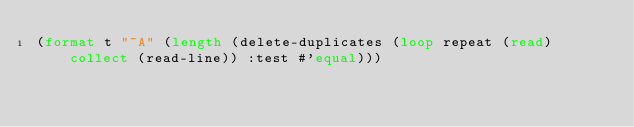Convert code to text. <code><loc_0><loc_0><loc_500><loc_500><_Lisp_>(format t "~A" (length (delete-duplicates (loop repeat (read) collect (read-line)) :test #'equal)))</code> 